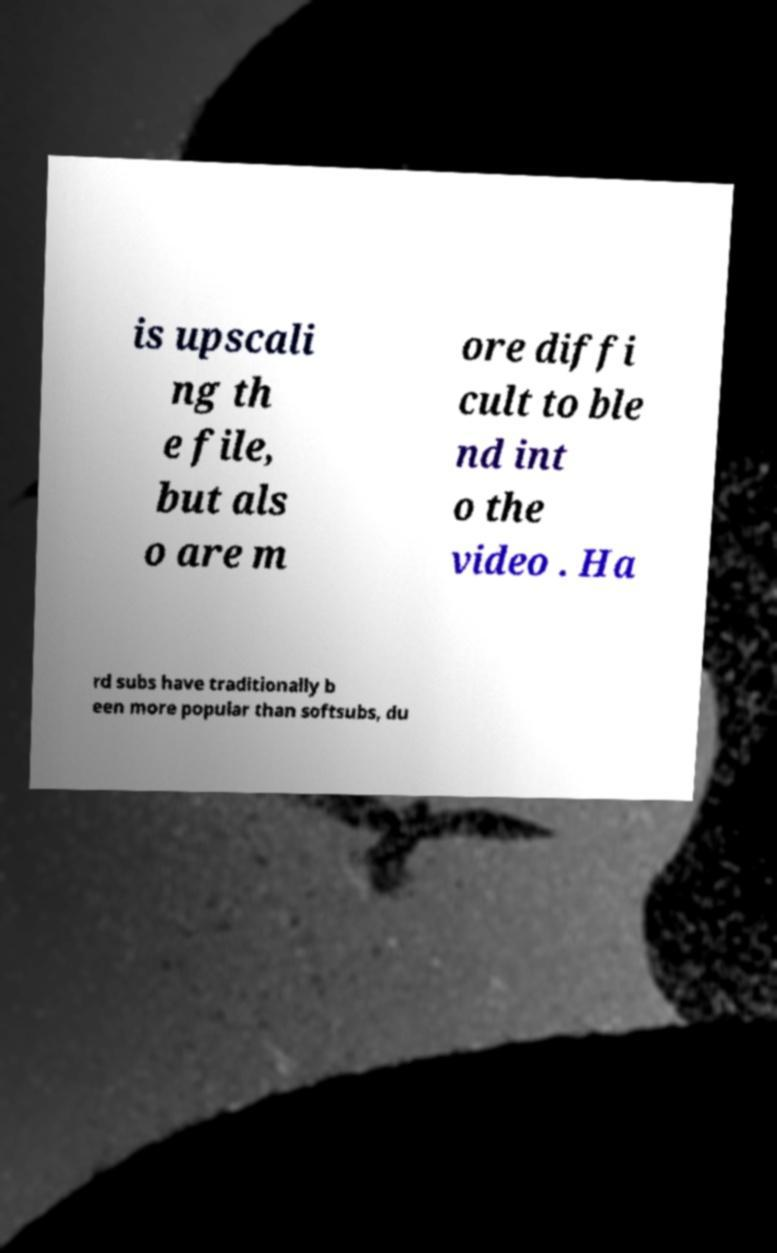Could you assist in decoding the text presented in this image and type it out clearly? is upscali ng th e file, but als o are m ore diffi cult to ble nd int o the video . Ha rd subs have traditionally b een more popular than softsubs, du 